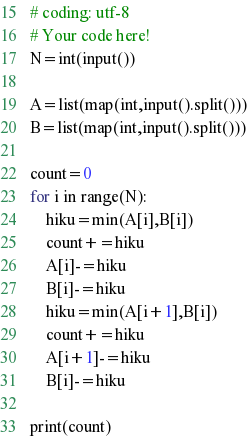Convert code to text. <code><loc_0><loc_0><loc_500><loc_500><_Python_># coding: utf-8
# Your code here!
N=int(input())

A=list(map(int,input().split()))
B=list(map(int,input().split()))

count=0
for i in range(N):
    hiku=min(A[i],B[i])
    count+=hiku
    A[i]-=hiku
    B[i]-=hiku
    hiku=min(A[i+1],B[i])
    count+=hiku
    A[i+1]-=hiku
    B[i]-=hiku

print(count)

</code> 